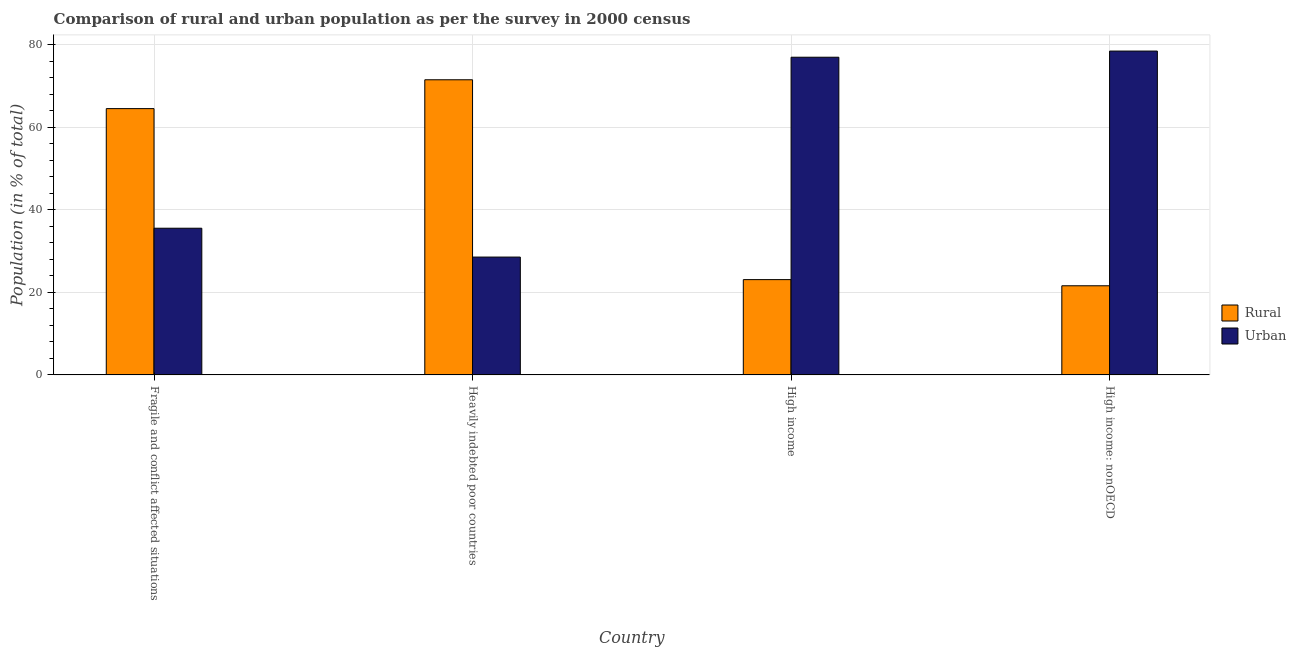How many different coloured bars are there?
Make the answer very short. 2. Are the number of bars on each tick of the X-axis equal?
Give a very brief answer. Yes. How many bars are there on the 4th tick from the left?
Give a very brief answer. 2. What is the label of the 2nd group of bars from the left?
Provide a succinct answer. Heavily indebted poor countries. What is the urban population in Heavily indebted poor countries?
Make the answer very short. 28.53. Across all countries, what is the maximum urban population?
Offer a terse response. 78.42. Across all countries, what is the minimum rural population?
Provide a succinct answer. 21.58. In which country was the rural population maximum?
Your response must be concise. Heavily indebted poor countries. In which country was the urban population minimum?
Ensure brevity in your answer.  Heavily indebted poor countries. What is the total rural population in the graph?
Provide a short and direct response. 180.6. What is the difference between the urban population in High income and that in High income: nonOECD?
Give a very brief answer. -1.49. What is the difference between the rural population in High income: nonOECD and the urban population in Fragile and conflict affected situations?
Your answer should be compact. -13.94. What is the average rural population per country?
Provide a short and direct response. 45.15. What is the difference between the rural population and urban population in Heavily indebted poor countries?
Your answer should be compact. 42.93. In how many countries, is the rural population greater than 64 %?
Provide a short and direct response. 2. What is the ratio of the rural population in Fragile and conflict affected situations to that in High income: nonOECD?
Offer a terse response. 2.99. Is the difference between the urban population in Heavily indebted poor countries and High income greater than the difference between the rural population in Heavily indebted poor countries and High income?
Offer a very short reply. No. What is the difference between the highest and the second highest rural population?
Give a very brief answer. 6.99. What is the difference between the highest and the lowest urban population?
Offer a terse response. 49.88. In how many countries, is the rural population greater than the average rural population taken over all countries?
Make the answer very short. 2. What does the 2nd bar from the left in Fragile and conflict affected situations represents?
Ensure brevity in your answer.  Urban. What does the 1st bar from the right in Heavily indebted poor countries represents?
Your answer should be compact. Urban. Are all the bars in the graph horizontal?
Offer a terse response. No. How many countries are there in the graph?
Keep it short and to the point. 4. What is the difference between two consecutive major ticks on the Y-axis?
Provide a short and direct response. 20. Does the graph contain any zero values?
Provide a succinct answer. No. Does the graph contain grids?
Offer a terse response. Yes. Where does the legend appear in the graph?
Offer a very short reply. Center right. How many legend labels are there?
Your response must be concise. 2. What is the title of the graph?
Offer a terse response. Comparison of rural and urban population as per the survey in 2000 census. Does "Stunting" appear as one of the legend labels in the graph?
Provide a short and direct response. No. What is the label or title of the X-axis?
Your answer should be very brief. Country. What is the label or title of the Y-axis?
Your response must be concise. Population (in % of total). What is the Population (in % of total) of Rural in Fragile and conflict affected situations?
Provide a succinct answer. 64.48. What is the Population (in % of total) of Urban in Fragile and conflict affected situations?
Ensure brevity in your answer.  35.52. What is the Population (in % of total) in Rural in Heavily indebted poor countries?
Give a very brief answer. 71.47. What is the Population (in % of total) of Urban in Heavily indebted poor countries?
Your answer should be compact. 28.53. What is the Population (in % of total) in Rural in High income?
Your answer should be very brief. 23.07. What is the Population (in % of total) of Urban in High income?
Offer a terse response. 76.93. What is the Population (in % of total) in Rural in High income: nonOECD?
Provide a short and direct response. 21.58. What is the Population (in % of total) of Urban in High income: nonOECD?
Ensure brevity in your answer.  78.42. Across all countries, what is the maximum Population (in % of total) in Rural?
Your answer should be very brief. 71.47. Across all countries, what is the maximum Population (in % of total) of Urban?
Your response must be concise. 78.42. Across all countries, what is the minimum Population (in % of total) of Rural?
Your response must be concise. 21.58. Across all countries, what is the minimum Population (in % of total) of Urban?
Ensure brevity in your answer.  28.53. What is the total Population (in % of total) in Rural in the graph?
Give a very brief answer. 180.6. What is the total Population (in % of total) of Urban in the graph?
Your answer should be very brief. 219.4. What is the difference between the Population (in % of total) in Rural in Fragile and conflict affected situations and that in Heavily indebted poor countries?
Give a very brief answer. -6.99. What is the difference between the Population (in % of total) of Urban in Fragile and conflict affected situations and that in Heavily indebted poor countries?
Offer a very short reply. 6.99. What is the difference between the Population (in % of total) of Rural in Fragile and conflict affected situations and that in High income?
Your answer should be very brief. 41.41. What is the difference between the Population (in % of total) of Urban in Fragile and conflict affected situations and that in High income?
Make the answer very short. -41.41. What is the difference between the Population (in % of total) in Rural in Fragile and conflict affected situations and that in High income: nonOECD?
Provide a succinct answer. 42.9. What is the difference between the Population (in % of total) in Urban in Fragile and conflict affected situations and that in High income: nonOECD?
Offer a very short reply. -42.9. What is the difference between the Population (in % of total) in Rural in Heavily indebted poor countries and that in High income?
Provide a succinct answer. 48.39. What is the difference between the Population (in % of total) in Urban in Heavily indebted poor countries and that in High income?
Offer a very short reply. -48.39. What is the difference between the Population (in % of total) in Rural in Heavily indebted poor countries and that in High income: nonOECD?
Provide a succinct answer. 49.88. What is the difference between the Population (in % of total) in Urban in Heavily indebted poor countries and that in High income: nonOECD?
Your response must be concise. -49.88. What is the difference between the Population (in % of total) in Rural in High income and that in High income: nonOECD?
Offer a terse response. 1.49. What is the difference between the Population (in % of total) of Urban in High income and that in High income: nonOECD?
Your answer should be compact. -1.49. What is the difference between the Population (in % of total) in Rural in Fragile and conflict affected situations and the Population (in % of total) in Urban in Heavily indebted poor countries?
Your answer should be compact. 35.95. What is the difference between the Population (in % of total) in Rural in Fragile and conflict affected situations and the Population (in % of total) in Urban in High income?
Offer a terse response. -12.45. What is the difference between the Population (in % of total) in Rural in Fragile and conflict affected situations and the Population (in % of total) in Urban in High income: nonOECD?
Your answer should be very brief. -13.94. What is the difference between the Population (in % of total) in Rural in Heavily indebted poor countries and the Population (in % of total) in Urban in High income?
Ensure brevity in your answer.  -5.46. What is the difference between the Population (in % of total) in Rural in Heavily indebted poor countries and the Population (in % of total) in Urban in High income: nonOECD?
Your answer should be compact. -6.95. What is the difference between the Population (in % of total) in Rural in High income and the Population (in % of total) in Urban in High income: nonOECD?
Make the answer very short. -55.34. What is the average Population (in % of total) in Rural per country?
Keep it short and to the point. 45.15. What is the average Population (in % of total) of Urban per country?
Make the answer very short. 54.85. What is the difference between the Population (in % of total) of Rural and Population (in % of total) of Urban in Fragile and conflict affected situations?
Give a very brief answer. 28.96. What is the difference between the Population (in % of total) of Rural and Population (in % of total) of Urban in Heavily indebted poor countries?
Your answer should be compact. 42.93. What is the difference between the Population (in % of total) in Rural and Population (in % of total) in Urban in High income?
Give a very brief answer. -53.85. What is the difference between the Population (in % of total) in Rural and Population (in % of total) in Urban in High income: nonOECD?
Offer a terse response. -56.83. What is the ratio of the Population (in % of total) in Rural in Fragile and conflict affected situations to that in Heavily indebted poor countries?
Give a very brief answer. 0.9. What is the ratio of the Population (in % of total) in Urban in Fragile and conflict affected situations to that in Heavily indebted poor countries?
Your answer should be very brief. 1.24. What is the ratio of the Population (in % of total) in Rural in Fragile and conflict affected situations to that in High income?
Provide a short and direct response. 2.79. What is the ratio of the Population (in % of total) of Urban in Fragile and conflict affected situations to that in High income?
Provide a succinct answer. 0.46. What is the ratio of the Population (in % of total) in Rural in Fragile and conflict affected situations to that in High income: nonOECD?
Provide a short and direct response. 2.99. What is the ratio of the Population (in % of total) of Urban in Fragile and conflict affected situations to that in High income: nonOECD?
Keep it short and to the point. 0.45. What is the ratio of the Population (in % of total) of Rural in Heavily indebted poor countries to that in High income?
Ensure brevity in your answer.  3.1. What is the ratio of the Population (in % of total) of Urban in Heavily indebted poor countries to that in High income?
Provide a succinct answer. 0.37. What is the ratio of the Population (in % of total) in Rural in Heavily indebted poor countries to that in High income: nonOECD?
Offer a very short reply. 3.31. What is the ratio of the Population (in % of total) in Urban in Heavily indebted poor countries to that in High income: nonOECD?
Your response must be concise. 0.36. What is the ratio of the Population (in % of total) of Rural in High income to that in High income: nonOECD?
Your response must be concise. 1.07. What is the ratio of the Population (in % of total) of Urban in High income to that in High income: nonOECD?
Ensure brevity in your answer.  0.98. What is the difference between the highest and the second highest Population (in % of total) of Rural?
Provide a short and direct response. 6.99. What is the difference between the highest and the second highest Population (in % of total) in Urban?
Provide a succinct answer. 1.49. What is the difference between the highest and the lowest Population (in % of total) of Rural?
Your response must be concise. 49.88. What is the difference between the highest and the lowest Population (in % of total) in Urban?
Provide a succinct answer. 49.88. 